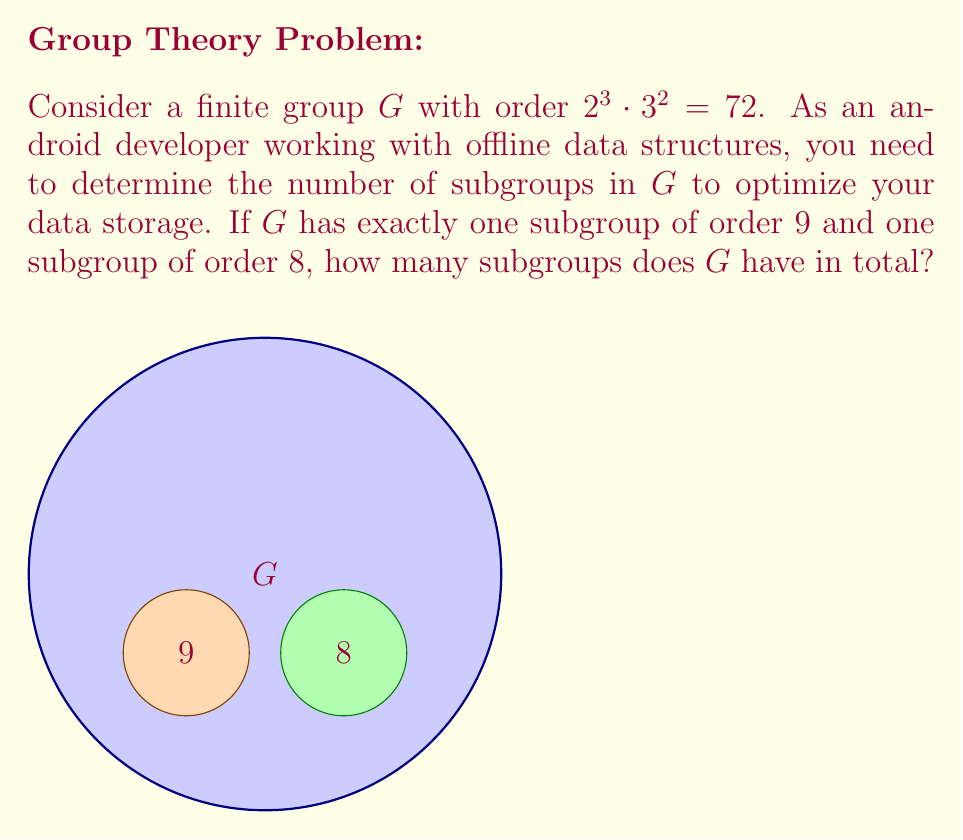What is the answer to this math problem? Let's approach this step-by-step:

1) First, recall Sylow's theorems:
   - For each prime factor $p$ of $|G|$, there exists at least one Sylow $p$-subgroup.
   - The number of Sylow $p$-subgroups is congruent to 1 mod $p$.

2) In this case, $|G| = 2^3 \cdot 3^2 = 72$. We need to consider Sylow 2-subgroups and Sylow 3-subgroups.

3) For Sylow 3-subgroups:
   - The order of a Sylow 3-subgroup is $3^2 = 9$.
   - We're given that there's exactly one subgroup of order 9.
   - This means there's only one Sylow 3-subgroup.

4) For Sylow 2-subgroups:
   - The order of a Sylow 2-subgroup is $2^3 = 8$.
   - We're given that there's exactly one subgroup of order 8.
   - This means there's only one Sylow 2-subgroup.

5) Now, let's list all possible subgroups:
   - The trivial subgroup {e} of order 1
   - The whole group G of order 72
   - The Sylow 3-subgroup of order 9
   - The Sylow 2-subgroup of order 8
   - Subgroups of order 2 (generated by elements of order 2)
   - Subgroups of order 3 (generated by elements of order 3)
   - Subgroups of order 4 (subgroups of the Sylow 2-subgroup)
   - Subgroups of order 6 (generated by combining elements of order 2 and 3)

6) To count these:
   - There's 1 subgroup each of orders 1, 72, 9, and 8
   - There's at most 1 subgroup of order 3 (as it's a subgroup of the unique Sylow 3-subgroup)
   - There's at most 1 subgroup of order 4 (as it's a subgroup of the unique Sylow 2-subgroup)
   - There can be multiple subgroups of order 2 and 6

7) The minimum number of subgroups is therefore 1 + 1 + 1 + 1 + 1 + 1 + 1 + 1 = 8

Therefore, G has at least 8 subgroups.
Answer: At least 8 subgroups 